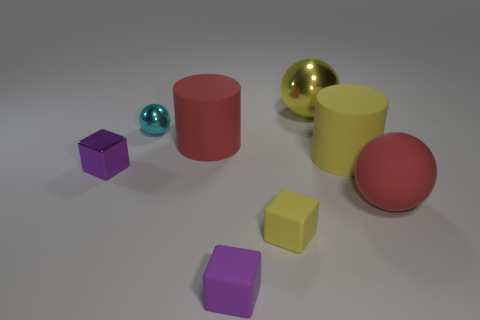What is the material of the big yellow cylinder?
Ensure brevity in your answer.  Rubber. There is a tiny object that is left of the cyan metal ball; what is its color?
Keep it short and to the point. Purple. What number of large cylinders are the same color as the large matte ball?
Provide a short and direct response. 1. How many things are in front of the big metallic ball and right of the tiny yellow rubber thing?
Offer a very short reply. 2. There is a yellow matte thing that is the same size as the cyan thing; what is its shape?
Keep it short and to the point. Cube. How big is the red rubber ball?
Your answer should be compact. Large. What is the material of the large ball that is in front of the metal object that is on the left side of the small sphere in front of the yellow ball?
Your response must be concise. Rubber. What color is the small ball that is made of the same material as the large yellow sphere?
Ensure brevity in your answer.  Cyan. How many red rubber balls are left of the yellow rubber thing that is in front of the large red rubber object that is right of the yellow block?
Provide a short and direct response. 0. What number of things are either big red matte objects to the left of the big red sphere or large purple objects?
Your answer should be very brief. 1. 